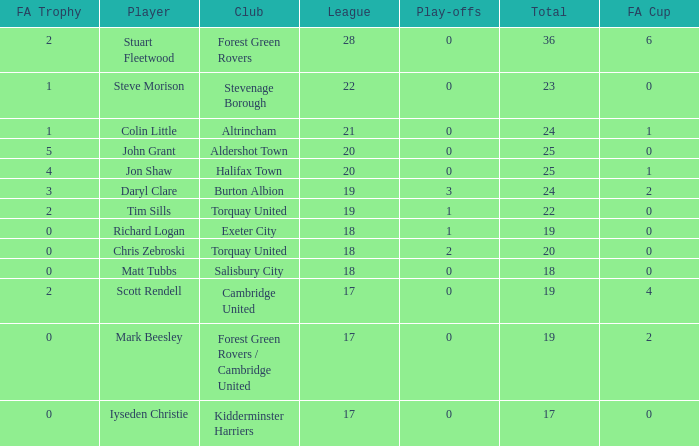Which of the lowest FA Trophys involved the Forest Green Rovers club when the play-offs number was bigger than 0? None. 